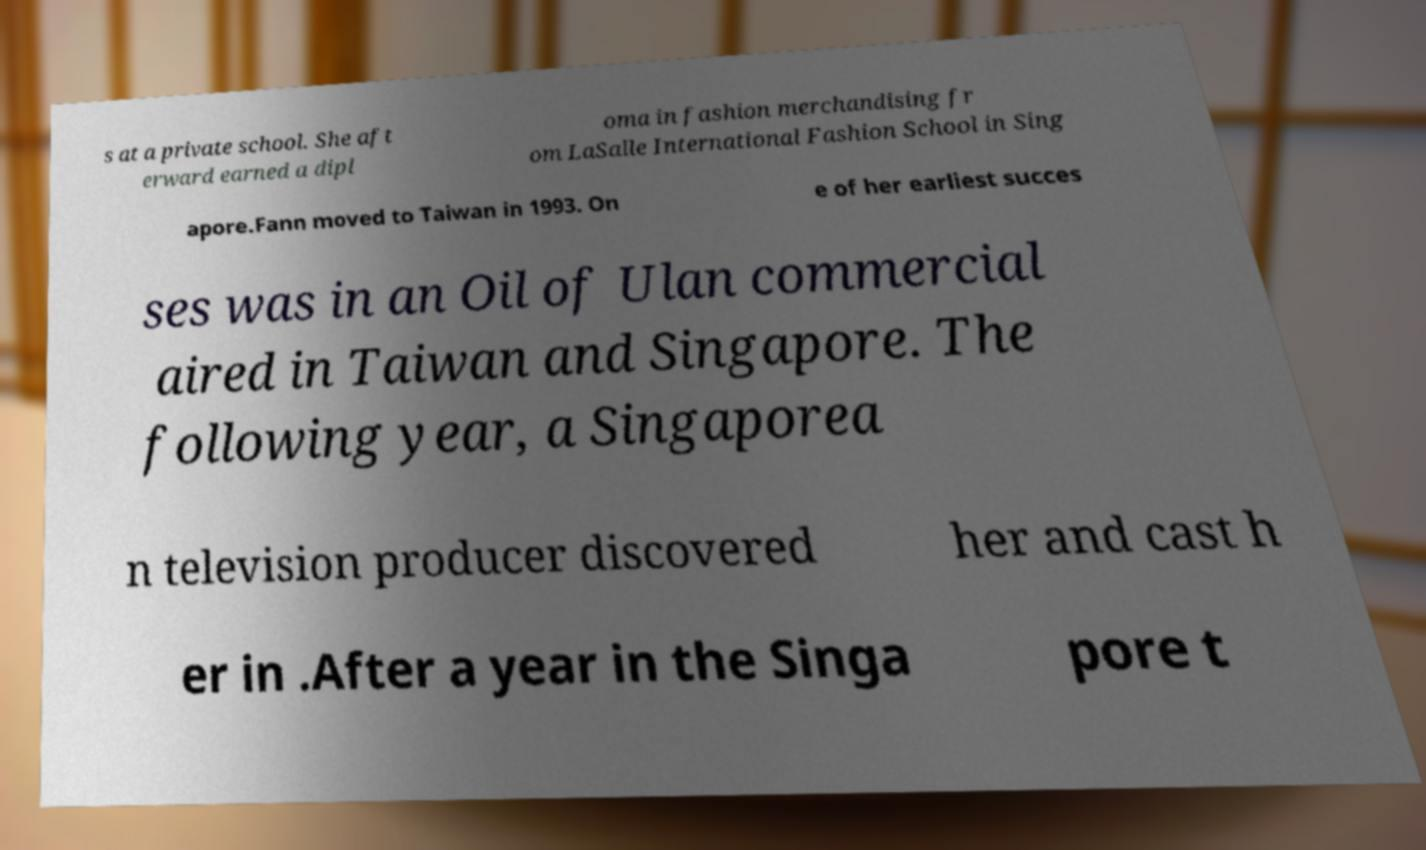Could you assist in decoding the text presented in this image and type it out clearly? s at a private school. She aft erward earned a dipl oma in fashion merchandising fr om LaSalle International Fashion School in Sing apore.Fann moved to Taiwan in 1993. On e of her earliest succes ses was in an Oil of Ulan commercial aired in Taiwan and Singapore. The following year, a Singaporea n television producer discovered her and cast h er in .After a year in the Singa pore t 